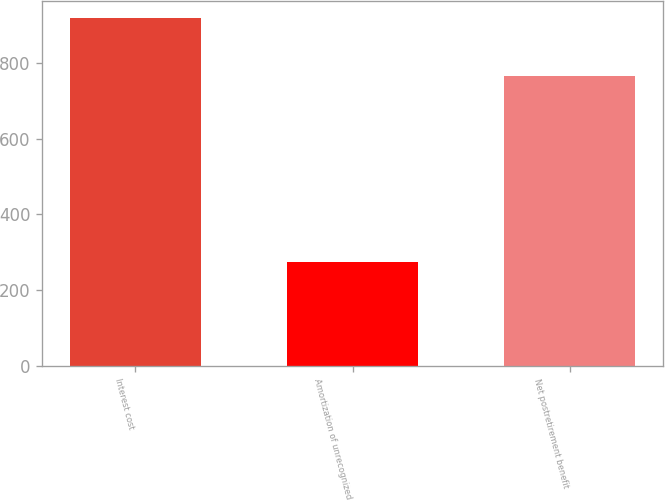Convert chart. <chart><loc_0><loc_0><loc_500><loc_500><bar_chart><fcel>Interest cost<fcel>Amortization of unrecognized<fcel>Net postretirement benefit<nl><fcel>919<fcel>275<fcel>766<nl></chart> 